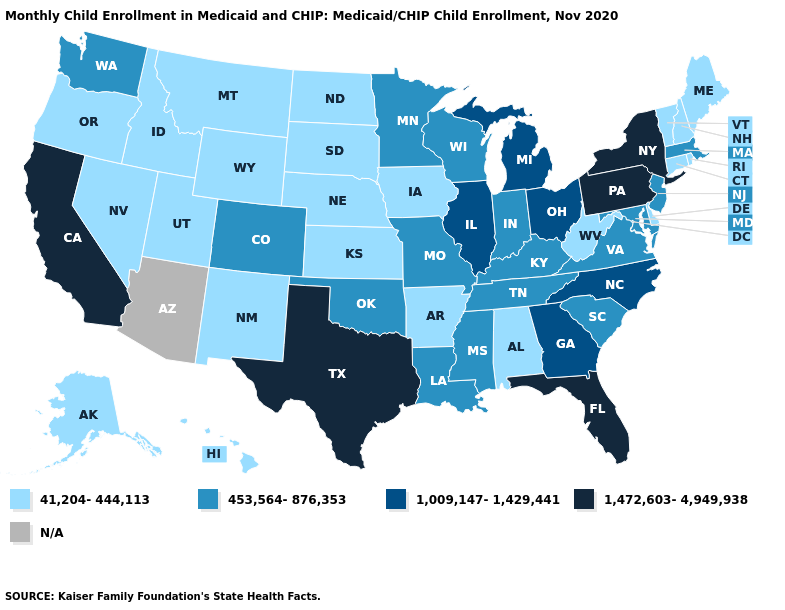Among the states that border Virginia , which have the lowest value?
Answer briefly. West Virginia. Name the states that have a value in the range 453,564-876,353?
Keep it brief. Colorado, Indiana, Kentucky, Louisiana, Maryland, Massachusetts, Minnesota, Mississippi, Missouri, New Jersey, Oklahoma, South Carolina, Tennessee, Virginia, Washington, Wisconsin. Does North Dakota have the highest value in the MidWest?
Quick response, please. No. Does Kentucky have the lowest value in the USA?
Be succinct. No. What is the value of Rhode Island?
Quick response, please. 41,204-444,113. What is the highest value in the USA?
Answer briefly. 1,472,603-4,949,938. Does the first symbol in the legend represent the smallest category?
Concise answer only. Yes. Does Connecticut have the lowest value in the Northeast?
Quick response, please. Yes. Name the states that have a value in the range 1,009,147-1,429,441?
Concise answer only. Georgia, Illinois, Michigan, North Carolina, Ohio. What is the value of Vermont?
Answer briefly. 41,204-444,113. Which states hav the highest value in the West?
Write a very short answer. California. Which states have the lowest value in the USA?
Concise answer only. Alabama, Alaska, Arkansas, Connecticut, Delaware, Hawaii, Idaho, Iowa, Kansas, Maine, Montana, Nebraska, Nevada, New Hampshire, New Mexico, North Dakota, Oregon, Rhode Island, South Dakota, Utah, Vermont, West Virginia, Wyoming. Name the states that have a value in the range 1,009,147-1,429,441?
Short answer required. Georgia, Illinois, Michigan, North Carolina, Ohio. What is the value of North Dakota?
Concise answer only. 41,204-444,113. 